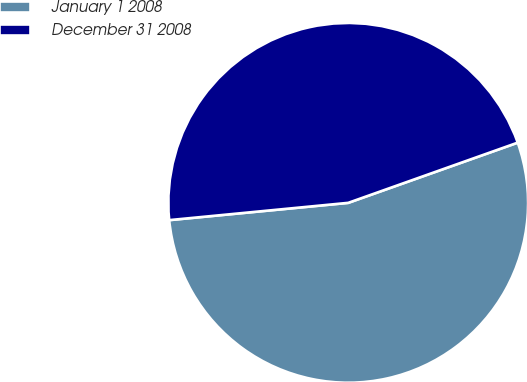<chart> <loc_0><loc_0><loc_500><loc_500><pie_chart><fcel>January 1 2008<fcel>December 31 2008<nl><fcel>53.9%<fcel>46.1%<nl></chart> 